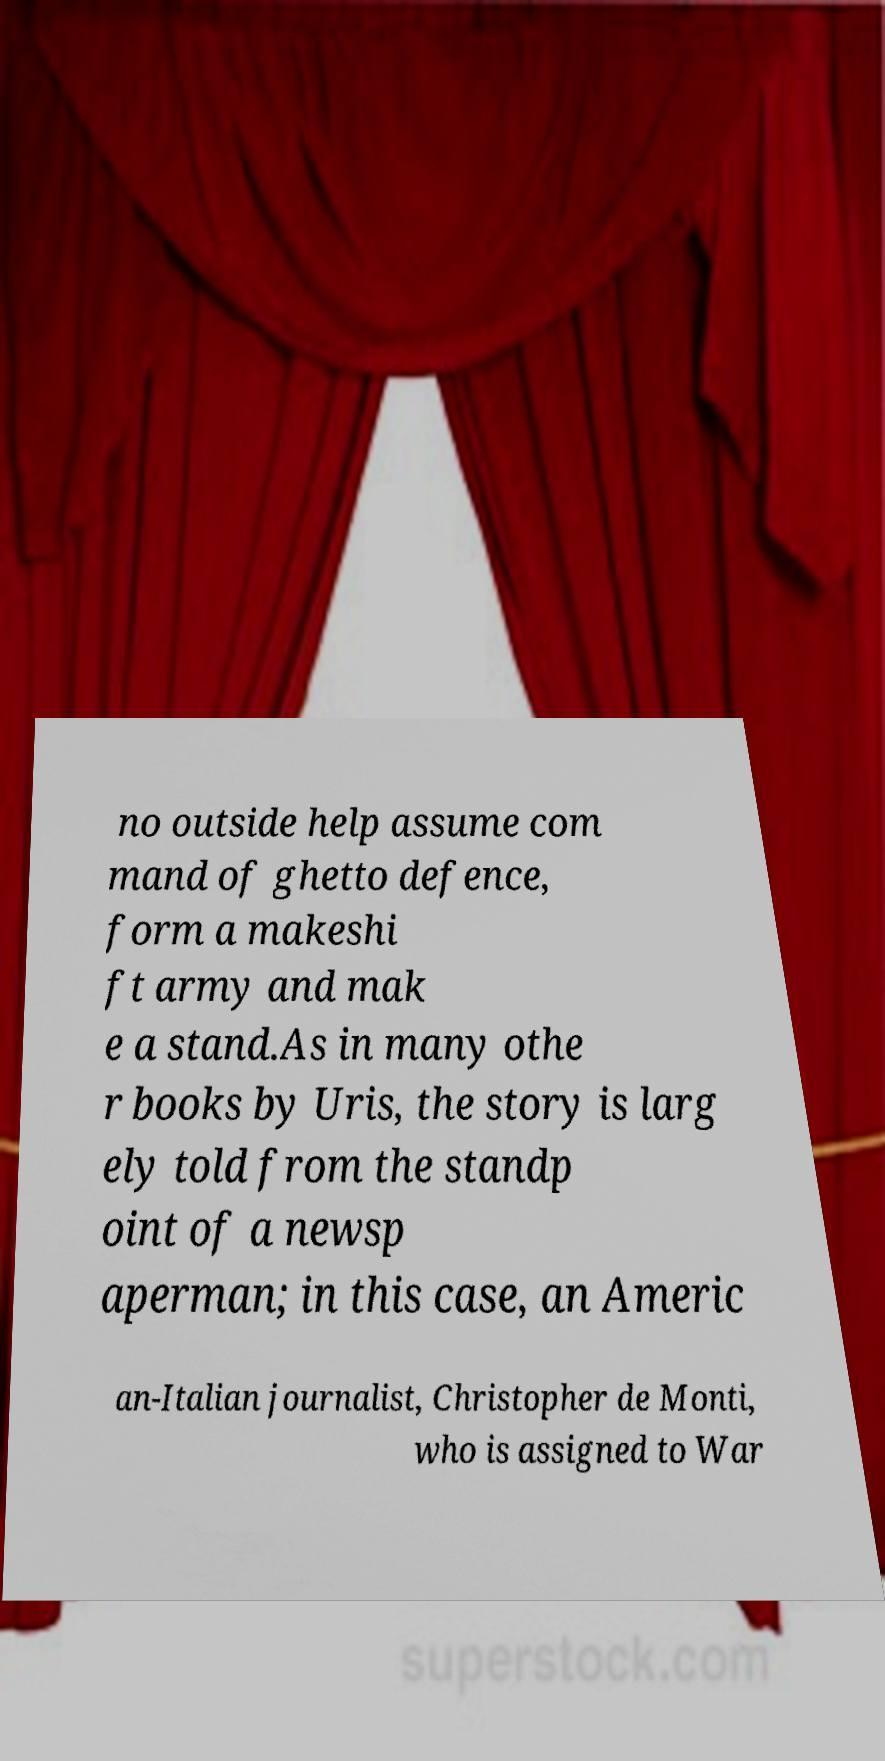Could you assist in decoding the text presented in this image and type it out clearly? no outside help assume com mand of ghetto defence, form a makeshi ft army and mak e a stand.As in many othe r books by Uris, the story is larg ely told from the standp oint of a newsp aperman; in this case, an Americ an-Italian journalist, Christopher de Monti, who is assigned to War 